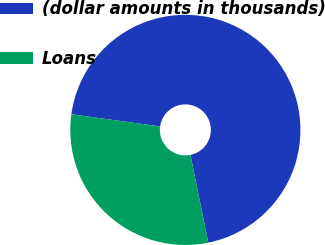Convert chart. <chart><loc_0><loc_0><loc_500><loc_500><pie_chart><fcel>(dollar amounts in thousands)<fcel>Loans<nl><fcel>69.63%<fcel>30.37%<nl></chart> 